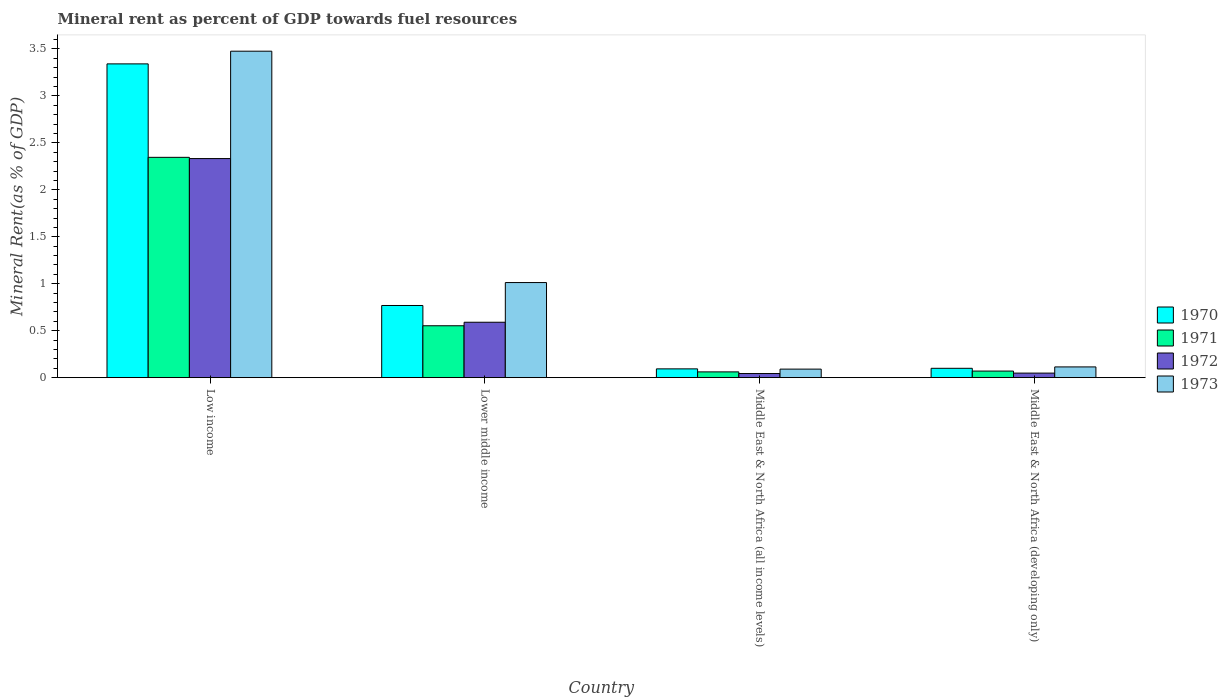How many different coloured bars are there?
Make the answer very short. 4. How many groups of bars are there?
Your response must be concise. 4. Are the number of bars per tick equal to the number of legend labels?
Provide a short and direct response. Yes. Are the number of bars on each tick of the X-axis equal?
Ensure brevity in your answer.  Yes. How many bars are there on the 4th tick from the left?
Ensure brevity in your answer.  4. How many bars are there on the 1st tick from the right?
Give a very brief answer. 4. What is the label of the 3rd group of bars from the left?
Make the answer very short. Middle East & North Africa (all income levels). In how many cases, is the number of bars for a given country not equal to the number of legend labels?
Offer a very short reply. 0. What is the mineral rent in 1970 in Middle East & North Africa (all income levels)?
Offer a very short reply. 0.09. Across all countries, what is the maximum mineral rent in 1971?
Offer a terse response. 2.35. Across all countries, what is the minimum mineral rent in 1973?
Provide a short and direct response. 0.09. In which country was the mineral rent in 1972 minimum?
Provide a succinct answer. Middle East & North Africa (all income levels). What is the total mineral rent in 1973 in the graph?
Offer a terse response. 4.69. What is the difference between the mineral rent in 1973 in Lower middle income and that in Middle East & North Africa (all income levels)?
Provide a succinct answer. 0.92. What is the difference between the mineral rent in 1973 in Middle East & North Africa (all income levels) and the mineral rent in 1971 in Low income?
Provide a succinct answer. -2.26. What is the average mineral rent in 1972 per country?
Your answer should be compact. 0.75. What is the difference between the mineral rent of/in 1972 and mineral rent of/in 1970 in Low income?
Your answer should be very brief. -1.01. What is the ratio of the mineral rent in 1971 in Low income to that in Lower middle income?
Give a very brief answer. 4.25. What is the difference between the highest and the second highest mineral rent in 1972?
Your response must be concise. -1.74. What is the difference between the highest and the lowest mineral rent in 1971?
Give a very brief answer. 2.28. What does the 2nd bar from the left in Middle East & North Africa (developing only) represents?
Offer a terse response. 1971. How many countries are there in the graph?
Ensure brevity in your answer.  4. What is the difference between two consecutive major ticks on the Y-axis?
Your answer should be compact. 0.5. Are the values on the major ticks of Y-axis written in scientific E-notation?
Give a very brief answer. No. Does the graph contain any zero values?
Offer a terse response. No. Where does the legend appear in the graph?
Keep it short and to the point. Center right. How many legend labels are there?
Your response must be concise. 4. How are the legend labels stacked?
Offer a terse response. Vertical. What is the title of the graph?
Your answer should be compact. Mineral rent as percent of GDP towards fuel resources. What is the label or title of the X-axis?
Your response must be concise. Country. What is the label or title of the Y-axis?
Ensure brevity in your answer.  Mineral Rent(as % of GDP). What is the Mineral Rent(as % of GDP) of 1970 in Low income?
Provide a succinct answer. 3.34. What is the Mineral Rent(as % of GDP) of 1971 in Low income?
Provide a short and direct response. 2.35. What is the Mineral Rent(as % of GDP) of 1972 in Low income?
Offer a terse response. 2.33. What is the Mineral Rent(as % of GDP) of 1973 in Low income?
Offer a very short reply. 3.48. What is the Mineral Rent(as % of GDP) of 1970 in Lower middle income?
Your answer should be compact. 0.77. What is the Mineral Rent(as % of GDP) of 1971 in Lower middle income?
Offer a terse response. 0.55. What is the Mineral Rent(as % of GDP) of 1972 in Lower middle income?
Make the answer very short. 0.59. What is the Mineral Rent(as % of GDP) in 1973 in Lower middle income?
Provide a succinct answer. 1.01. What is the Mineral Rent(as % of GDP) of 1970 in Middle East & North Africa (all income levels)?
Give a very brief answer. 0.09. What is the Mineral Rent(as % of GDP) of 1971 in Middle East & North Africa (all income levels)?
Provide a succinct answer. 0.06. What is the Mineral Rent(as % of GDP) of 1972 in Middle East & North Africa (all income levels)?
Offer a very short reply. 0.04. What is the Mineral Rent(as % of GDP) of 1973 in Middle East & North Africa (all income levels)?
Give a very brief answer. 0.09. What is the Mineral Rent(as % of GDP) of 1970 in Middle East & North Africa (developing only)?
Give a very brief answer. 0.1. What is the Mineral Rent(as % of GDP) in 1971 in Middle East & North Africa (developing only)?
Offer a terse response. 0.07. What is the Mineral Rent(as % of GDP) in 1972 in Middle East & North Africa (developing only)?
Keep it short and to the point. 0.05. What is the Mineral Rent(as % of GDP) in 1973 in Middle East & North Africa (developing only)?
Your response must be concise. 0.11. Across all countries, what is the maximum Mineral Rent(as % of GDP) in 1970?
Your answer should be very brief. 3.34. Across all countries, what is the maximum Mineral Rent(as % of GDP) in 1971?
Make the answer very short. 2.35. Across all countries, what is the maximum Mineral Rent(as % of GDP) in 1972?
Offer a terse response. 2.33. Across all countries, what is the maximum Mineral Rent(as % of GDP) of 1973?
Offer a terse response. 3.48. Across all countries, what is the minimum Mineral Rent(as % of GDP) of 1970?
Your answer should be very brief. 0.09. Across all countries, what is the minimum Mineral Rent(as % of GDP) in 1971?
Your response must be concise. 0.06. Across all countries, what is the minimum Mineral Rent(as % of GDP) of 1972?
Your answer should be compact. 0.04. Across all countries, what is the minimum Mineral Rent(as % of GDP) in 1973?
Make the answer very short. 0.09. What is the total Mineral Rent(as % of GDP) in 1970 in the graph?
Give a very brief answer. 4.3. What is the total Mineral Rent(as % of GDP) in 1971 in the graph?
Offer a terse response. 3.03. What is the total Mineral Rent(as % of GDP) in 1972 in the graph?
Provide a succinct answer. 3.02. What is the total Mineral Rent(as % of GDP) of 1973 in the graph?
Your answer should be compact. 4.69. What is the difference between the Mineral Rent(as % of GDP) of 1970 in Low income and that in Lower middle income?
Your answer should be very brief. 2.57. What is the difference between the Mineral Rent(as % of GDP) in 1971 in Low income and that in Lower middle income?
Offer a very short reply. 1.79. What is the difference between the Mineral Rent(as % of GDP) in 1972 in Low income and that in Lower middle income?
Your answer should be very brief. 1.74. What is the difference between the Mineral Rent(as % of GDP) in 1973 in Low income and that in Lower middle income?
Ensure brevity in your answer.  2.46. What is the difference between the Mineral Rent(as % of GDP) in 1970 in Low income and that in Middle East & North Africa (all income levels)?
Ensure brevity in your answer.  3.25. What is the difference between the Mineral Rent(as % of GDP) in 1971 in Low income and that in Middle East & North Africa (all income levels)?
Your answer should be very brief. 2.28. What is the difference between the Mineral Rent(as % of GDP) in 1972 in Low income and that in Middle East & North Africa (all income levels)?
Make the answer very short. 2.29. What is the difference between the Mineral Rent(as % of GDP) of 1973 in Low income and that in Middle East & North Africa (all income levels)?
Provide a short and direct response. 3.39. What is the difference between the Mineral Rent(as % of GDP) in 1970 in Low income and that in Middle East & North Africa (developing only)?
Your response must be concise. 3.24. What is the difference between the Mineral Rent(as % of GDP) in 1971 in Low income and that in Middle East & North Africa (developing only)?
Provide a short and direct response. 2.28. What is the difference between the Mineral Rent(as % of GDP) in 1972 in Low income and that in Middle East & North Africa (developing only)?
Make the answer very short. 2.28. What is the difference between the Mineral Rent(as % of GDP) of 1973 in Low income and that in Middle East & North Africa (developing only)?
Give a very brief answer. 3.36. What is the difference between the Mineral Rent(as % of GDP) in 1970 in Lower middle income and that in Middle East & North Africa (all income levels)?
Make the answer very short. 0.67. What is the difference between the Mineral Rent(as % of GDP) in 1971 in Lower middle income and that in Middle East & North Africa (all income levels)?
Make the answer very short. 0.49. What is the difference between the Mineral Rent(as % of GDP) of 1972 in Lower middle income and that in Middle East & North Africa (all income levels)?
Give a very brief answer. 0.55. What is the difference between the Mineral Rent(as % of GDP) in 1973 in Lower middle income and that in Middle East & North Africa (all income levels)?
Keep it short and to the point. 0.92. What is the difference between the Mineral Rent(as % of GDP) in 1970 in Lower middle income and that in Middle East & North Africa (developing only)?
Keep it short and to the point. 0.67. What is the difference between the Mineral Rent(as % of GDP) in 1971 in Lower middle income and that in Middle East & North Africa (developing only)?
Make the answer very short. 0.48. What is the difference between the Mineral Rent(as % of GDP) in 1972 in Lower middle income and that in Middle East & North Africa (developing only)?
Offer a terse response. 0.54. What is the difference between the Mineral Rent(as % of GDP) of 1973 in Lower middle income and that in Middle East & North Africa (developing only)?
Provide a succinct answer. 0.9. What is the difference between the Mineral Rent(as % of GDP) in 1970 in Middle East & North Africa (all income levels) and that in Middle East & North Africa (developing only)?
Give a very brief answer. -0.01. What is the difference between the Mineral Rent(as % of GDP) in 1971 in Middle East & North Africa (all income levels) and that in Middle East & North Africa (developing only)?
Give a very brief answer. -0.01. What is the difference between the Mineral Rent(as % of GDP) of 1972 in Middle East & North Africa (all income levels) and that in Middle East & North Africa (developing only)?
Provide a succinct answer. -0. What is the difference between the Mineral Rent(as % of GDP) of 1973 in Middle East & North Africa (all income levels) and that in Middle East & North Africa (developing only)?
Ensure brevity in your answer.  -0.02. What is the difference between the Mineral Rent(as % of GDP) of 1970 in Low income and the Mineral Rent(as % of GDP) of 1971 in Lower middle income?
Your answer should be compact. 2.79. What is the difference between the Mineral Rent(as % of GDP) of 1970 in Low income and the Mineral Rent(as % of GDP) of 1972 in Lower middle income?
Your answer should be compact. 2.75. What is the difference between the Mineral Rent(as % of GDP) in 1970 in Low income and the Mineral Rent(as % of GDP) in 1973 in Lower middle income?
Provide a short and direct response. 2.33. What is the difference between the Mineral Rent(as % of GDP) in 1971 in Low income and the Mineral Rent(as % of GDP) in 1972 in Lower middle income?
Make the answer very short. 1.76. What is the difference between the Mineral Rent(as % of GDP) of 1971 in Low income and the Mineral Rent(as % of GDP) of 1973 in Lower middle income?
Provide a short and direct response. 1.33. What is the difference between the Mineral Rent(as % of GDP) in 1972 in Low income and the Mineral Rent(as % of GDP) in 1973 in Lower middle income?
Keep it short and to the point. 1.32. What is the difference between the Mineral Rent(as % of GDP) of 1970 in Low income and the Mineral Rent(as % of GDP) of 1971 in Middle East & North Africa (all income levels)?
Offer a terse response. 3.28. What is the difference between the Mineral Rent(as % of GDP) in 1970 in Low income and the Mineral Rent(as % of GDP) in 1972 in Middle East & North Africa (all income levels)?
Your response must be concise. 3.3. What is the difference between the Mineral Rent(as % of GDP) in 1970 in Low income and the Mineral Rent(as % of GDP) in 1973 in Middle East & North Africa (all income levels)?
Your answer should be compact. 3.25. What is the difference between the Mineral Rent(as % of GDP) in 1971 in Low income and the Mineral Rent(as % of GDP) in 1972 in Middle East & North Africa (all income levels)?
Keep it short and to the point. 2.3. What is the difference between the Mineral Rent(as % of GDP) of 1971 in Low income and the Mineral Rent(as % of GDP) of 1973 in Middle East & North Africa (all income levels)?
Ensure brevity in your answer.  2.26. What is the difference between the Mineral Rent(as % of GDP) in 1972 in Low income and the Mineral Rent(as % of GDP) in 1973 in Middle East & North Africa (all income levels)?
Ensure brevity in your answer.  2.24. What is the difference between the Mineral Rent(as % of GDP) of 1970 in Low income and the Mineral Rent(as % of GDP) of 1971 in Middle East & North Africa (developing only)?
Your answer should be compact. 3.27. What is the difference between the Mineral Rent(as % of GDP) of 1970 in Low income and the Mineral Rent(as % of GDP) of 1972 in Middle East & North Africa (developing only)?
Give a very brief answer. 3.29. What is the difference between the Mineral Rent(as % of GDP) of 1970 in Low income and the Mineral Rent(as % of GDP) of 1973 in Middle East & North Africa (developing only)?
Provide a succinct answer. 3.23. What is the difference between the Mineral Rent(as % of GDP) of 1971 in Low income and the Mineral Rent(as % of GDP) of 1972 in Middle East & North Africa (developing only)?
Your answer should be compact. 2.3. What is the difference between the Mineral Rent(as % of GDP) in 1971 in Low income and the Mineral Rent(as % of GDP) in 1973 in Middle East & North Africa (developing only)?
Ensure brevity in your answer.  2.23. What is the difference between the Mineral Rent(as % of GDP) of 1972 in Low income and the Mineral Rent(as % of GDP) of 1973 in Middle East & North Africa (developing only)?
Keep it short and to the point. 2.22. What is the difference between the Mineral Rent(as % of GDP) of 1970 in Lower middle income and the Mineral Rent(as % of GDP) of 1971 in Middle East & North Africa (all income levels)?
Your answer should be compact. 0.71. What is the difference between the Mineral Rent(as % of GDP) of 1970 in Lower middle income and the Mineral Rent(as % of GDP) of 1972 in Middle East & North Africa (all income levels)?
Ensure brevity in your answer.  0.72. What is the difference between the Mineral Rent(as % of GDP) of 1970 in Lower middle income and the Mineral Rent(as % of GDP) of 1973 in Middle East & North Africa (all income levels)?
Offer a terse response. 0.68. What is the difference between the Mineral Rent(as % of GDP) in 1971 in Lower middle income and the Mineral Rent(as % of GDP) in 1972 in Middle East & North Africa (all income levels)?
Make the answer very short. 0.51. What is the difference between the Mineral Rent(as % of GDP) of 1971 in Lower middle income and the Mineral Rent(as % of GDP) of 1973 in Middle East & North Africa (all income levels)?
Keep it short and to the point. 0.46. What is the difference between the Mineral Rent(as % of GDP) of 1972 in Lower middle income and the Mineral Rent(as % of GDP) of 1973 in Middle East & North Africa (all income levels)?
Make the answer very short. 0.5. What is the difference between the Mineral Rent(as % of GDP) in 1970 in Lower middle income and the Mineral Rent(as % of GDP) in 1971 in Middle East & North Africa (developing only)?
Your answer should be compact. 0.7. What is the difference between the Mineral Rent(as % of GDP) of 1970 in Lower middle income and the Mineral Rent(as % of GDP) of 1972 in Middle East & North Africa (developing only)?
Provide a short and direct response. 0.72. What is the difference between the Mineral Rent(as % of GDP) in 1970 in Lower middle income and the Mineral Rent(as % of GDP) in 1973 in Middle East & North Africa (developing only)?
Your response must be concise. 0.65. What is the difference between the Mineral Rent(as % of GDP) in 1971 in Lower middle income and the Mineral Rent(as % of GDP) in 1972 in Middle East & North Africa (developing only)?
Provide a succinct answer. 0.5. What is the difference between the Mineral Rent(as % of GDP) in 1971 in Lower middle income and the Mineral Rent(as % of GDP) in 1973 in Middle East & North Africa (developing only)?
Give a very brief answer. 0.44. What is the difference between the Mineral Rent(as % of GDP) in 1972 in Lower middle income and the Mineral Rent(as % of GDP) in 1973 in Middle East & North Africa (developing only)?
Your answer should be very brief. 0.48. What is the difference between the Mineral Rent(as % of GDP) of 1970 in Middle East & North Africa (all income levels) and the Mineral Rent(as % of GDP) of 1971 in Middle East & North Africa (developing only)?
Keep it short and to the point. 0.02. What is the difference between the Mineral Rent(as % of GDP) of 1970 in Middle East & North Africa (all income levels) and the Mineral Rent(as % of GDP) of 1972 in Middle East & North Africa (developing only)?
Keep it short and to the point. 0.04. What is the difference between the Mineral Rent(as % of GDP) in 1970 in Middle East & North Africa (all income levels) and the Mineral Rent(as % of GDP) in 1973 in Middle East & North Africa (developing only)?
Your answer should be compact. -0.02. What is the difference between the Mineral Rent(as % of GDP) of 1971 in Middle East & North Africa (all income levels) and the Mineral Rent(as % of GDP) of 1972 in Middle East & North Africa (developing only)?
Offer a terse response. 0.01. What is the difference between the Mineral Rent(as % of GDP) of 1971 in Middle East & North Africa (all income levels) and the Mineral Rent(as % of GDP) of 1973 in Middle East & North Africa (developing only)?
Provide a succinct answer. -0.05. What is the difference between the Mineral Rent(as % of GDP) of 1972 in Middle East & North Africa (all income levels) and the Mineral Rent(as % of GDP) of 1973 in Middle East & North Africa (developing only)?
Make the answer very short. -0.07. What is the average Mineral Rent(as % of GDP) of 1970 per country?
Keep it short and to the point. 1.08. What is the average Mineral Rent(as % of GDP) in 1971 per country?
Your answer should be very brief. 0.76. What is the average Mineral Rent(as % of GDP) of 1972 per country?
Provide a succinct answer. 0.75. What is the average Mineral Rent(as % of GDP) of 1973 per country?
Provide a short and direct response. 1.17. What is the difference between the Mineral Rent(as % of GDP) of 1970 and Mineral Rent(as % of GDP) of 1972 in Low income?
Offer a terse response. 1.01. What is the difference between the Mineral Rent(as % of GDP) of 1970 and Mineral Rent(as % of GDP) of 1973 in Low income?
Make the answer very short. -0.14. What is the difference between the Mineral Rent(as % of GDP) of 1971 and Mineral Rent(as % of GDP) of 1972 in Low income?
Offer a terse response. 0.01. What is the difference between the Mineral Rent(as % of GDP) of 1971 and Mineral Rent(as % of GDP) of 1973 in Low income?
Keep it short and to the point. -1.13. What is the difference between the Mineral Rent(as % of GDP) of 1972 and Mineral Rent(as % of GDP) of 1973 in Low income?
Offer a terse response. -1.14. What is the difference between the Mineral Rent(as % of GDP) in 1970 and Mineral Rent(as % of GDP) in 1971 in Lower middle income?
Offer a terse response. 0.22. What is the difference between the Mineral Rent(as % of GDP) of 1970 and Mineral Rent(as % of GDP) of 1972 in Lower middle income?
Ensure brevity in your answer.  0.18. What is the difference between the Mineral Rent(as % of GDP) in 1970 and Mineral Rent(as % of GDP) in 1973 in Lower middle income?
Give a very brief answer. -0.24. What is the difference between the Mineral Rent(as % of GDP) in 1971 and Mineral Rent(as % of GDP) in 1972 in Lower middle income?
Your answer should be very brief. -0.04. What is the difference between the Mineral Rent(as % of GDP) in 1971 and Mineral Rent(as % of GDP) in 1973 in Lower middle income?
Your answer should be compact. -0.46. What is the difference between the Mineral Rent(as % of GDP) of 1972 and Mineral Rent(as % of GDP) of 1973 in Lower middle income?
Keep it short and to the point. -0.42. What is the difference between the Mineral Rent(as % of GDP) in 1970 and Mineral Rent(as % of GDP) in 1971 in Middle East & North Africa (all income levels)?
Ensure brevity in your answer.  0.03. What is the difference between the Mineral Rent(as % of GDP) of 1970 and Mineral Rent(as % of GDP) of 1972 in Middle East & North Africa (all income levels)?
Give a very brief answer. 0.05. What is the difference between the Mineral Rent(as % of GDP) of 1970 and Mineral Rent(as % of GDP) of 1973 in Middle East & North Africa (all income levels)?
Your answer should be compact. 0. What is the difference between the Mineral Rent(as % of GDP) of 1971 and Mineral Rent(as % of GDP) of 1972 in Middle East & North Africa (all income levels)?
Provide a short and direct response. 0.02. What is the difference between the Mineral Rent(as % of GDP) of 1971 and Mineral Rent(as % of GDP) of 1973 in Middle East & North Africa (all income levels)?
Give a very brief answer. -0.03. What is the difference between the Mineral Rent(as % of GDP) in 1972 and Mineral Rent(as % of GDP) in 1973 in Middle East & North Africa (all income levels)?
Your answer should be compact. -0.05. What is the difference between the Mineral Rent(as % of GDP) of 1970 and Mineral Rent(as % of GDP) of 1971 in Middle East & North Africa (developing only)?
Your response must be concise. 0.03. What is the difference between the Mineral Rent(as % of GDP) of 1970 and Mineral Rent(as % of GDP) of 1972 in Middle East & North Africa (developing only)?
Provide a short and direct response. 0.05. What is the difference between the Mineral Rent(as % of GDP) of 1970 and Mineral Rent(as % of GDP) of 1973 in Middle East & North Africa (developing only)?
Make the answer very short. -0.01. What is the difference between the Mineral Rent(as % of GDP) of 1971 and Mineral Rent(as % of GDP) of 1972 in Middle East & North Africa (developing only)?
Your answer should be compact. 0.02. What is the difference between the Mineral Rent(as % of GDP) of 1971 and Mineral Rent(as % of GDP) of 1973 in Middle East & North Africa (developing only)?
Ensure brevity in your answer.  -0.04. What is the difference between the Mineral Rent(as % of GDP) in 1972 and Mineral Rent(as % of GDP) in 1973 in Middle East & North Africa (developing only)?
Your response must be concise. -0.07. What is the ratio of the Mineral Rent(as % of GDP) in 1970 in Low income to that in Lower middle income?
Offer a terse response. 4.35. What is the ratio of the Mineral Rent(as % of GDP) in 1971 in Low income to that in Lower middle income?
Make the answer very short. 4.25. What is the ratio of the Mineral Rent(as % of GDP) of 1972 in Low income to that in Lower middle income?
Provide a short and direct response. 3.95. What is the ratio of the Mineral Rent(as % of GDP) of 1973 in Low income to that in Lower middle income?
Give a very brief answer. 3.43. What is the ratio of the Mineral Rent(as % of GDP) in 1970 in Low income to that in Middle East & North Africa (all income levels)?
Give a very brief answer. 35.68. What is the ratio of the Mineral Rent(as % of GDP) of 1971 in Low income to that in Middle East & North Africa (all income levels)?
Ensure brevity in your answer.  38.13. What is the ratio of the Mineral Rent(as % of GDP) of 1972 in Low income to that in Middle East & North Africa (all income levels)?
Offer a very short reply. 53.05. What is the ratio of the Mineral Rent(as % of GDP) of 1973 in Low income to that in Middle East & North Africa (all income levels)?
Your answer should be very brief. 38.18. What is the ratio of the Mineral Rent(as % of GDP) in 1970 in Low income to that in Middle East & North Africa (developing only)?
Ensure brevity in your answer.  33.55. What is the ratio of the Mineral Rent(as % of GDP) of 1971 in Low income to that in Middle East & North Africa (developing only)?
Offer a terse response. 33.42. What is the ratio of the Mineral Rent(as % of GDP) of 1972 in Low income to that in Middle East & North Africa (developing only)?
Make the answer very short. 47.95. What is the ratio of the Mineral Rent(as % of GDP) of 1973 in Low income to that in Middle East & North Africa (developing only)?
Your answer should be compact. 30.36. What is the ratio of the Mineral Rent(as % of GDP) of 1970 in Lower middle income to that in Middle East & North Africa (all income levels)?
Offer a terse response. 8.21. What is the ratio of the Mineral Rent(as % of GDP) of 1971 in Lower middle income to that in Middle East & North Africa (all income levels)?
Your answer should be compact. 8.98. What is the ratio of the Mineral Rent(as % of GDP) in 1972 in Lower middle income to that in Middle East & North Africa (all income levels)?
Ensure brevity in your answer.  13.42. What is the ratio of the Mineral Rent(as % of GDP) in 1973 in Lower middle income to that in Middle East & North Africa (all income levels)?
Give a very brief answer. 11.12. What is the ratio of the Mineral Rent(as % of GDP) of 1970 in Lower middle income to that in Middle East & North Africa (developing only)?
Provide a short and direct response. 7.72. What is the ratio of the Mineral Rent(as % of GDP) in 1971 in Lower middle income to that in Middle East & North Africa (developing only)?
Offer a terse response. 7.87. What is the ratio of the Mineral Rent(as % of GDP) in 1972 in Lower middle income to that in Middle East & North Africa (developing only)?
Your answer should be compact. 12.13. What is the ratio of the Mineral Rent(as % of GDP) in 1973 in Lower middle income to that in Middle East & North Africa (developing only)?
Your answer should be compact. 8.85. What is the ratio of the Mineral Rent(as % of GDP) in 1970 in Middle East & North Africa (all income levels) to that in Middle East & North Africa (developing only)?
Provide a short and direct response. 0.94. What is the ratio of the Mineral Rent(as % of GDP) of 1971 in Middle East & North Africa (all income levels) to that in Middle East & North Africa (developing only)?
Give a very brief answer. 0.88. What is the ratio of the Mineral Rent(as % of GDP) of 1972 in Middle East & North Africa (all income levels) to that in Middle East & North Africa (developing only)?
Your answer should be very brief. 0.9. What is the ratio of the Mineral Rent(as % of GDP) in 1973 in Middle East & North Africa (all income levels) to that in Middle East & North Africa (developing only)?
Provide a short and direct response. 0.8. What is the difference between the highest and the second highest Mineral Rent(as % of GDP) in 1970?
Ensure brevity in your answer.  2.57. What is the difference between the highest and the second highest Mineral Rent(as % of GDP) in 1971?
Give a very brief answer. 1.79. What is the difference between the highest and the second highest Mineral Rent(as % of GDP) of 1972?
Make the answer very short. 1.74. What is the difference between the highest and the second highest Mineral Rent(as % of GDP) of 1973?
Your response must be concise. 2.46. What is the difference between the highest and the lowest Mineral Rent(as % of GDP) of 1970?
Give a very brief answer. 3.25. What is the difference between the highest and the lowest Mineral Rent(as % of GDP) of 1971?
Provide a succinct answer. 2.28. What is the difference between the highest and the lowest Mineral Rent(as % of GDP) in 1972?
Your answer should be compact. 2.29. What is the difference between the highest and the lowest Mineral Rent(as % of GDP) in 1973?
Your answer should be very brief. 3.39. 